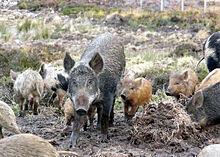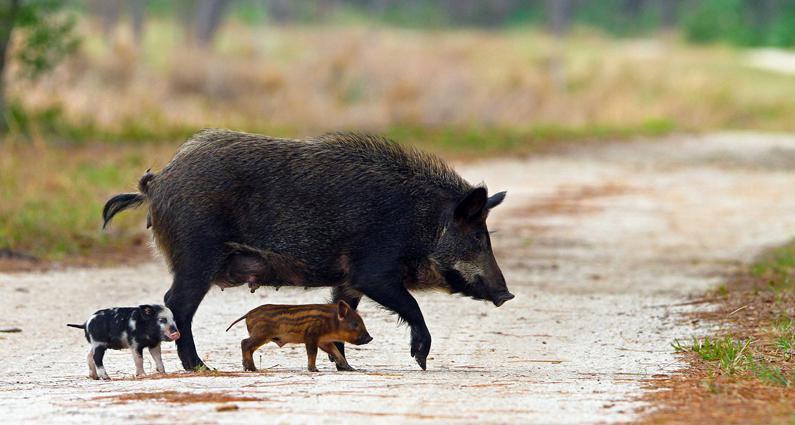The first image is the image on the left, the second image is the image on the right. Examine the images to the left and right. Is the description "An image shows only an adult boar, and no other animals." accurate? Answer yes or no. No. 